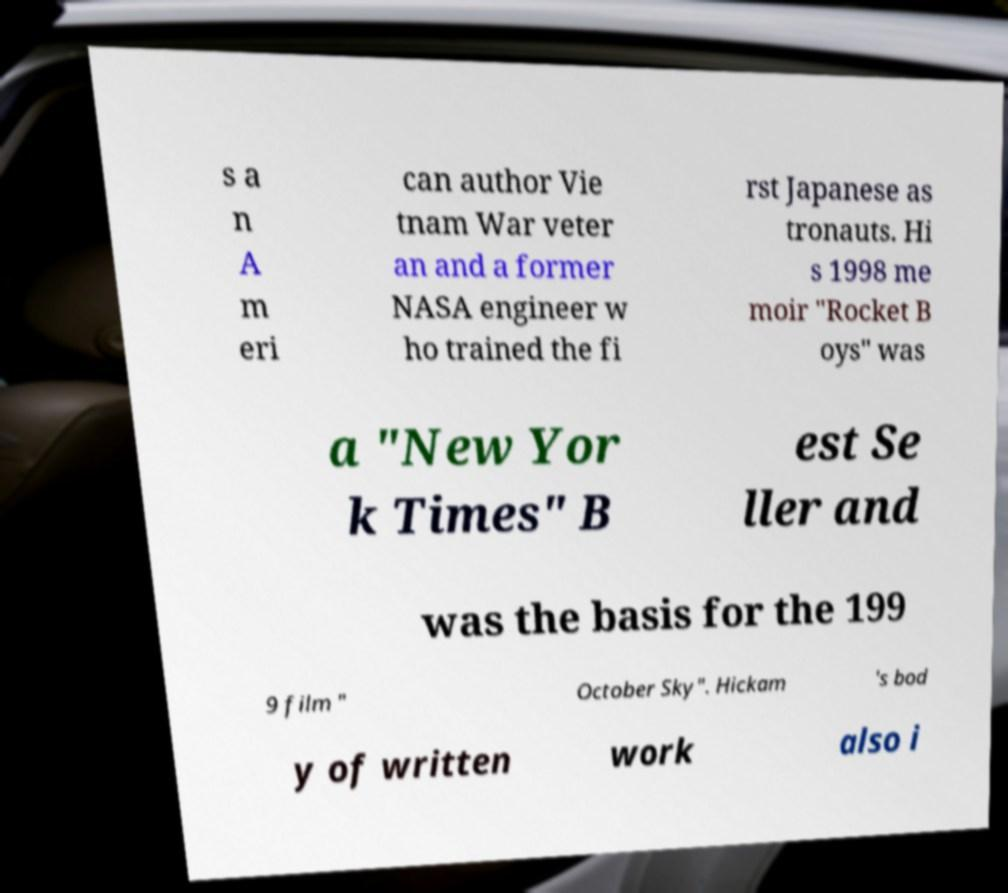There's text embedded in this image that I need extracted. Can you transcribe it verbatim? s a n A m eri can author Vie tnam War veter an and a former NASA engineer w ho trained the fi rst Japanese as tronauts. Hi s 1998 me moir "Rocket B oys" was a "New Yor k Times" B est Se ller and was the basis for the 199 9 film " October Sky". Hickam 's bod y of written work also i 